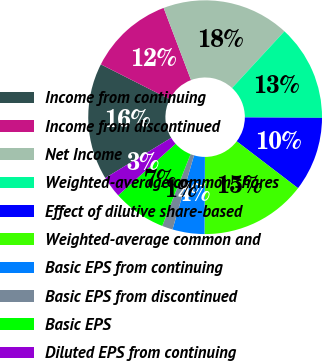<chart> <loc_0><loc_0><loc_500><loc_500><pie_chart><fcel>Income from continuing<fcel>Income from discontinued<fcel>Net Income<fcel>Weighted-average common shares<fcel>Effect of dilutive share-based<fcel>Weighted-average common and<fcel>Basic EPS from continuing<fcel>Basic EPS from discontinued<fcel>Basic EPS<fcel>Diluted EPS from continuing<nl><fcel>16.17%<fcel>11.76%<fcel>17.64%<fcel>13.23%<fcel>10.29%<fcel>14.7%<fcel>4.42%<fcel>1.48%<fcel>7.36%<fcel>2.95%<nl></chart> 